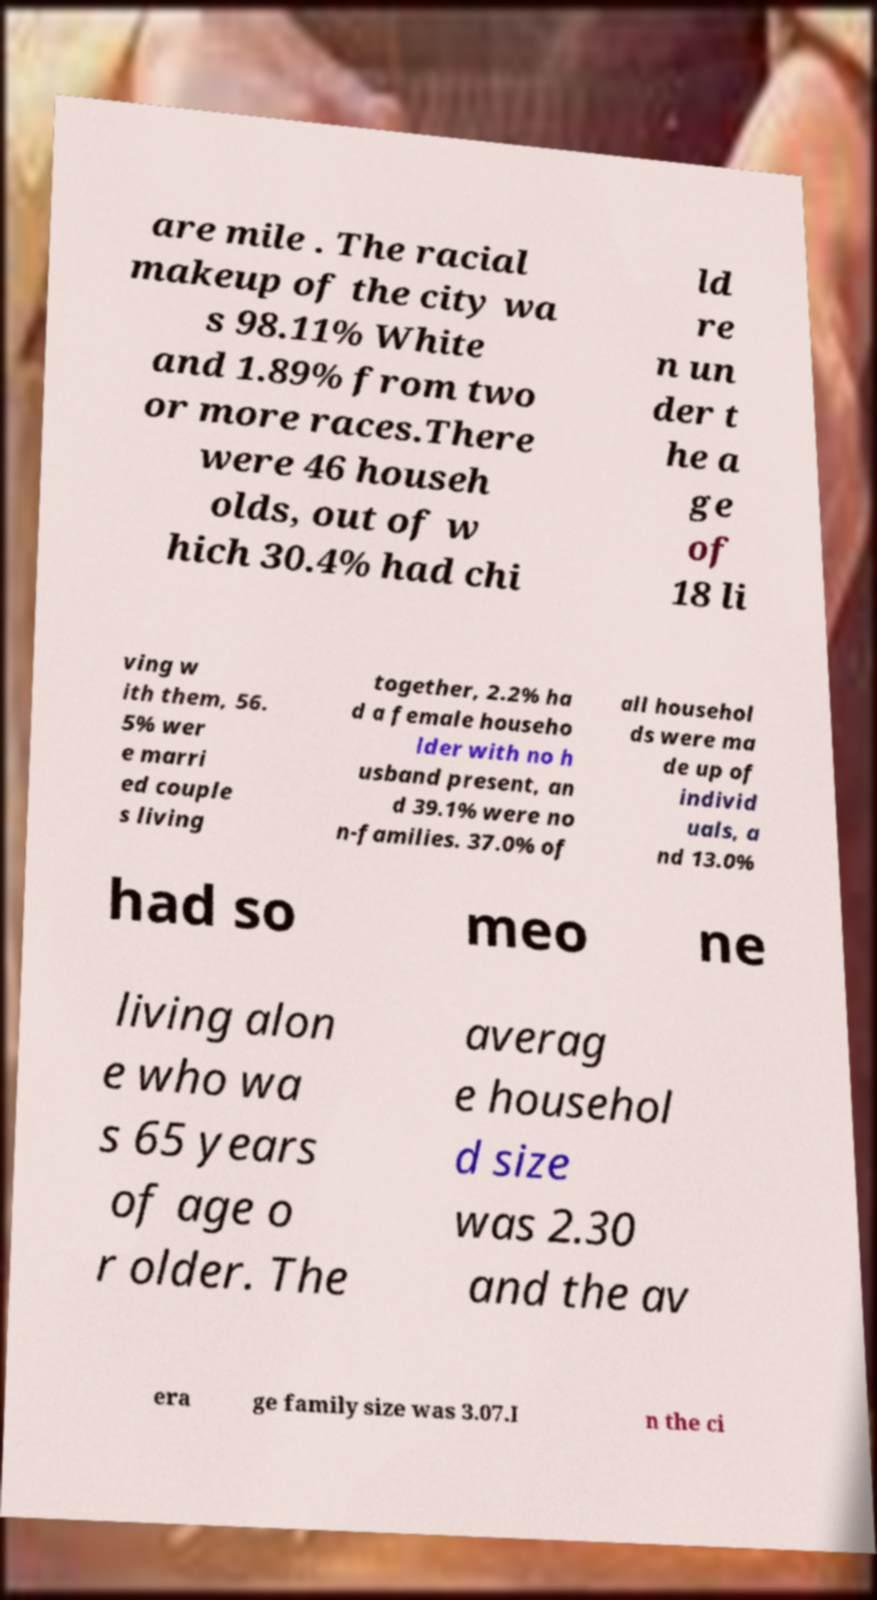Can you read and provide the text displayed in the image?This photo seems to have some interesting text. Can you extract and type it out for me? are mile . The racial makeup of the city wa s 98.11% White and 1.89% from two or more races.There were 46 househ olds, out of w hich 30.4% had chi ld re n un der t he a ge of 18 li ving w ith them, 56. 5% wer e marri ed couple s living together, 2.2% ha d a female househo lder with no h usband present, an d 39.1% were no n-families. 37.0% of all househol ds were ma de up of individ uals, a nd 13.0% had so meo ne living alon e who wa s 65 years of age o r older. The averag e househol d size was 2.30 and the av era ge family size was 3.07.I n the ci 